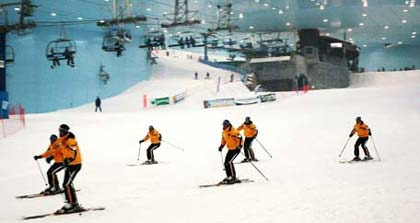Are there any flags or markers on the slope? Yes, there are red markers or flags placed at several points on the slope. These likely serve to demarcate certain areas or to provide a path or route for the skiers to follow. 